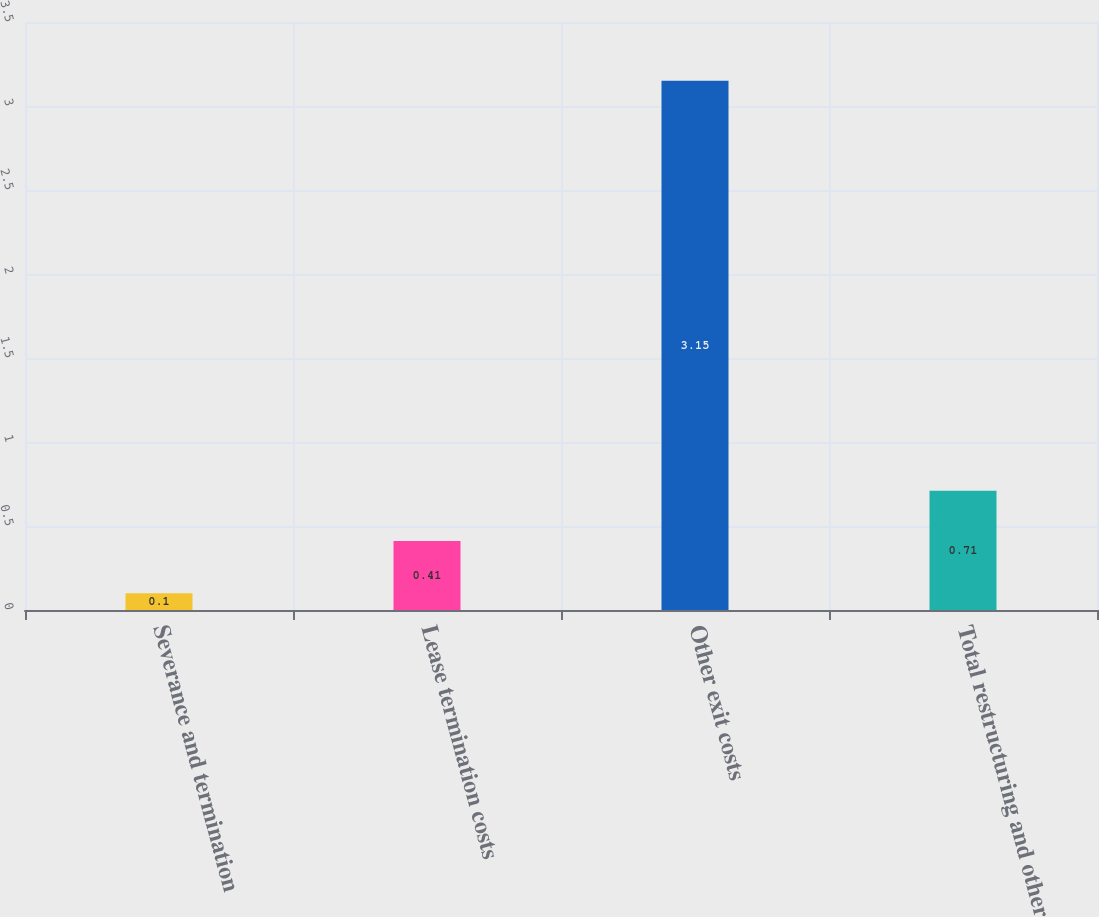Convert chart. <chart><loc_0><loc_0><loc_500><loc_500><bar_chart><fcel>Severance and termination<fcel>Lease termination costs<fcel>Other exit costs<fcel>Total restructuring and other<nl><fcel>0.1<fcel>0.41<fcel>3.15<fcel>0.71<nl></chart> 